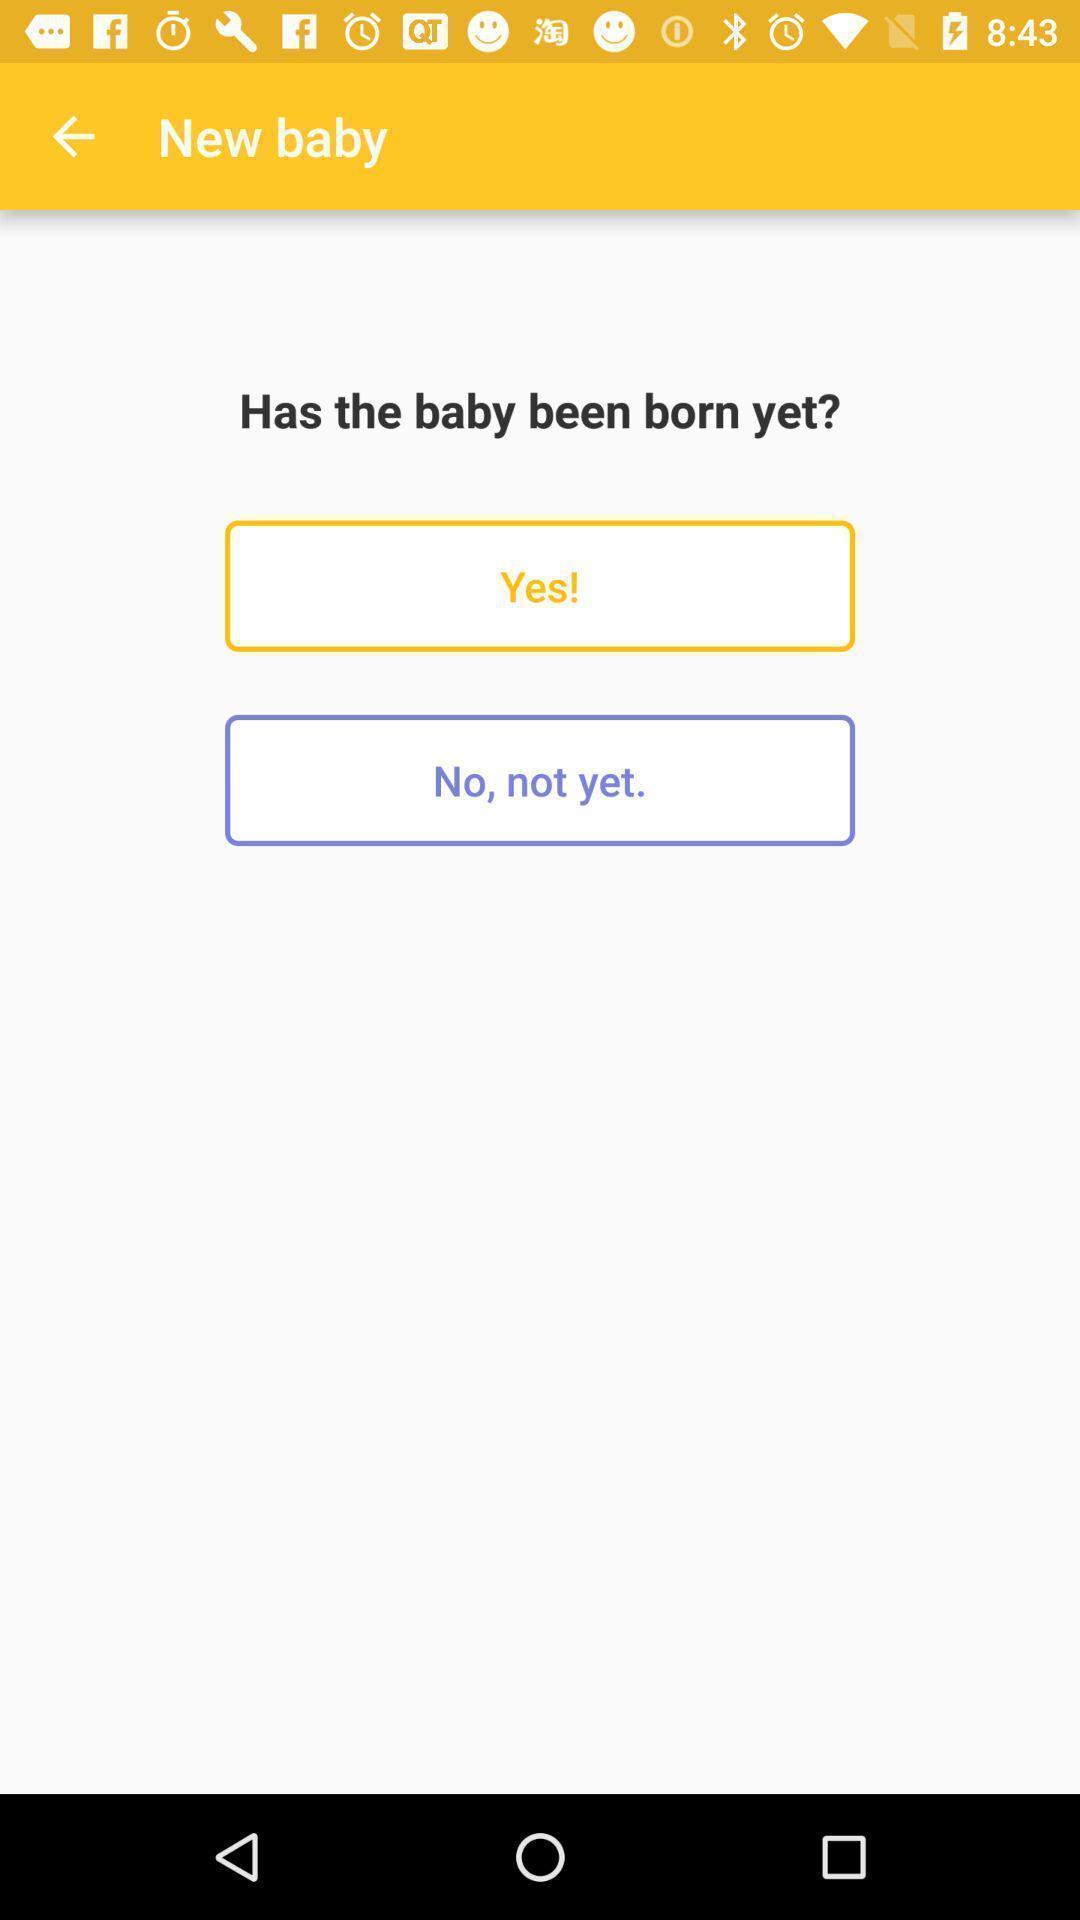Provide a detailed account of this screenshot. Screen shows information about new baby. 